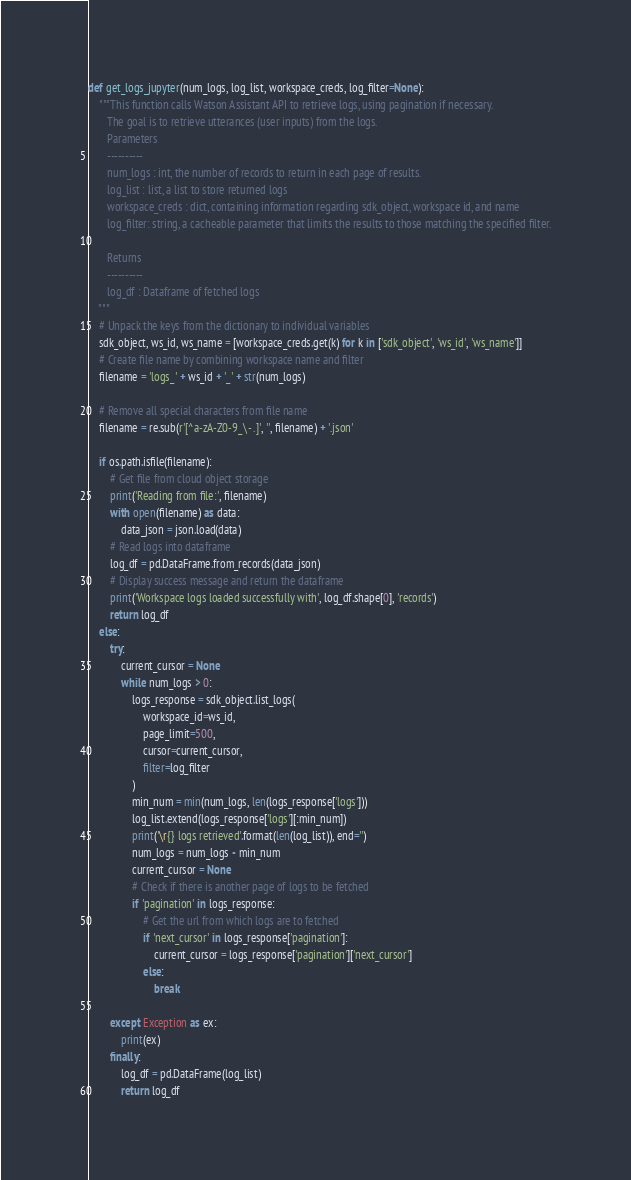<code> <loc_0><loc_0><loc_500><loc_500><_Python_>

def get_logs_jupyter(num_logs, log_list, workspace_creds, log_filter=None):
    """This function calls Watson Assistant API to retrieve logs, using pagination if necessary.
       The goal is to retrieve utterances (user inputs) from the logs.
       Parameters
       ----------
       num_logs : int, the number of records to return in each page of results.
       log_list : list, a list to store returned logs
       workspace_creds : dict, containing information regarding sdk_object, workspace id, and name
       log_filter: string, a cacheable parameter that limits the results to those matching the specified filter.

       Returns
       ----------
       log_df : Dataframe of fetched logs
    """
    # Unpack the keys from the dictionary to individual variables
    sdk_object, ws_id, ws_name = [workspace_creds.get(k) for k in ['sdk_object', 'ws_id', 'ws_name']]
    # Create file name by combining workspace name and filter
    filename = 'logs_' + ws_id + '_' + str(num_logs)

    # Remove all special characters from file name
    filename = re.sub(r'[^a-zA-Z0-9_\- .]', '', filename) + '.json'

    if os.path.isfile(filename):
        # Get file from cloud object storage
        print('Reading from file:', filename)
        with open(filename) as data:
            data_json = json.load(data)
        # Read logs into dataframe
        log_df = pd.DataFrame.from_records(data_json)
        # Display success message and return the dataframe
        print('Workspace logs loaded successfully with', log_df.shape[0], 'records')
        return log_df
    else:
        try:
            current_cursor = None
            while num_logs > 0:
                logs_response = sdk_object.list_logs(
                    workspace_id=ws_id,
                    page_limit=500,
                    cursor=current_cursor,
                    filter=log_filter
                )
                min_num = min(num_logs, len(logs_response['logs']))
                log_list.extend(logs_response['logs'][:min_num])
                print('\r{} logs retrieved'.format(len(log_list)), end='')
                num_logs = num_logs - min_num
                current_cursor = None
                # Check if there is another page of logs to be fetched
                if 'pagination' in logs_response:
                    # Get the url from which logs are to fetched
                    if 'next_cursor' in logs_response['pagination']:
                        current_cursor = logs_response['pagination']['next_cursor']
                    else:
                        break

        except Exception as ex:
            print(ex)
        finally:
            log_df = pd.DataFrame(log_list)
            return log_df
</code> 